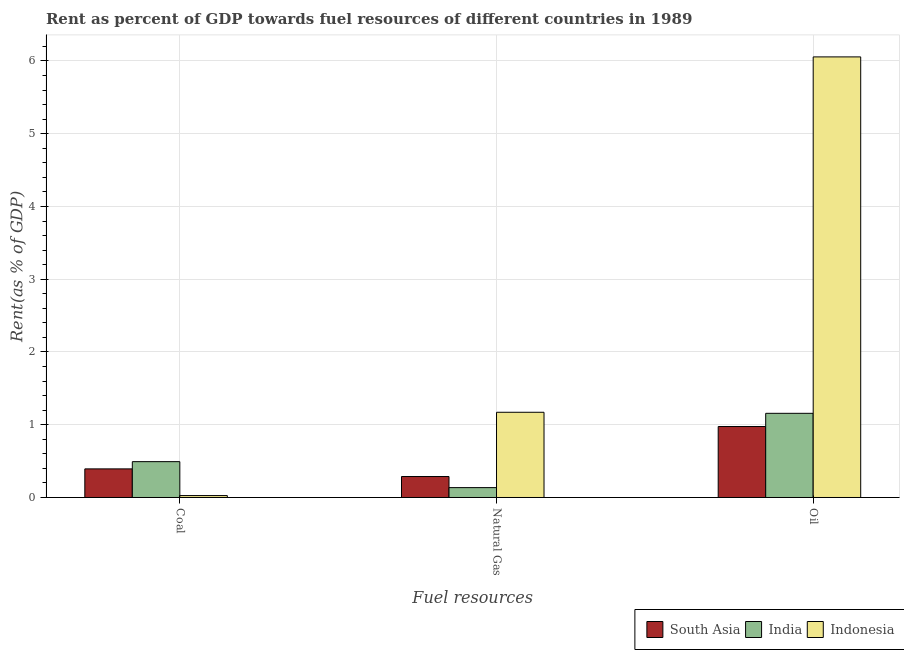How many different coloured bars are there?
Provide a short and direct response. 3. How many bars are there on the 3rd tick from the left?
Your response must be concise. 3. What is the label of the 2nd group of bars from the left?
Keep it short and to the point. Natural Gas. What is the rent towards natural gas in South Asia?
Your answer should be compact. 0.29. Across all countries, what is the maximum rent towards oil?
Keep it short and to the point. 6.06. Across all countries, what is the minimum rent towards coal?
Ensure brevity in your answer.  0.03. In which country was the rent towards coal maximum?
Make the answer very short. India. In which country was the rent towards coal minimum?
Give a very brief answer. Indonesia. What is the total rent towards oil in the graph?
Provide a short and direct response. 8.19. What is the difference between the rent towards oil in South Asia and that in India?
Make the answer very short. -0.18. What is the difference between the rent towards coal in South Asia and the rent towards natural gas in Indonesia?
Keep it short and to the point. -0.78. What is the average rent towards natural gas per country?
Keep it short and to the point. 0.53. What is the difference between the rent towards coal and rent towards oil in Indonesia?
Keep it short and to the point. -6.03. In how many countries, is the rent towards natural gas greater than 1.6 %?
Give a very brief answer. 0. What is the ratio of the rent towards coal in India to that in Indonesia?
Your response must be concise. 18.74. Is the rent towards oil in India less than that in South Asia?
Keep it short and to the point. No. Is the difference between the rent towards coal in India and South Asia greater than the difference between the rent towards natural gas in India and South Asia?
Provide a succinct answer. Yes. What is the difference between the highest and the second highest rent towards oil?
Provide a succinct answer. 4.9. What is the difference between the highest and the lowest rent towards natural gas?
Your answer should be very brief. 1.04. In how many countries, is the rent towards oil greater than the average rent towards oil taken over all countries?
Your answer should be compact. 1. What does the 2nd bar from the left in Coal represents?
Your answer should be very brief. India. What does the 1st bar from the right in Oil represents?
Keep it short and to the point. Indonesia. Are the values on the major ticks of Y-axis written in scientific E-notation?
Keep it short and to the point. No. Does the graph contain grids?
Provide a succinct answer. Yes. How many legend labels are there?
Provide a succinct answer. 3. How are the legend labels stacked?
Offer a very short reply. Horizontal. What is the title of the graph?
Offer a terse response. Rent as percent of GDP towards fuel resources of different countries in 1989. Does "Honduras" appear as one of the legend labels in the graph?
Ensure brevity in your answer.  No. What is the label or title of the X-axis?
Offer a very short reply. Fuel resources. What is the label or title of the Y-axis?
Give a very brief answer. Rent(as % of GDP). What is the Rent(as % of GDP) in South Asia in Coal?
Give a very brief answer. 0.39. What is the Rent(as % of GDP) of India in Coal?
Ensure brevity in your answer.  0.49. What is the Rent(as % of GDP) of Indonesia in Coal?
Make the answer very short. 0.03. What is the Rent(as % of GDP) in South Asia in Natural Gas?
Ensure brevity in your answer.  0.29. What is the Rent(as % of GDP) in India in Natural Gas?
Ensure brevity in your answer.  0.14. What is the Rent(as % of GDP) in Indonesia in Natural Gas?
Give a very brief answer. 1.17. What is the Rent(as % of GDP) of South Asia in Oil?
Keep it short and to the point. 0.98. What is the Rent(as % of GDP) in India in Oil?
Offer a terse response. 1.16. What is the Rent(as % of GDP) of Indonesia in Oil?
Keep it short and to the point. 6.06. Across all Fuel resources, what is the maximum Rent(as % of GDP) of South Asia?
Ensure brevity in your answer.  0.98. Across all Fuel resources, what is the maximum Rent(as % of GDP) of India?
Provide a succinct answer. 1.16. Across all Fuel resources, what is the maximum Rent(as % of GDP) of Indonesia?
Offer a terse response. 6.06. Across all Fuel resources, what is the minimum Rent(as % of GDP) of South Asia?
Your answer should be compact. 0.29. Across all Fuel resources, what is the minimum Rent(as % of GDP) of India?
Ensure brevity in your answer.  0.14. Across all Fuel resources, what is the minimum Rent(as % of GDP) in Indonesia?
Your response must be concise. 0.03. What is the total Rent(as % of GDP) of South Asia in the graph?
Provide a short and direct response. 1.66. What is the total Rent(as % of GDP) in India in the graph?
Provide a short and direct response. 1.78. What is the total Rent(as % of GDP) of Indonesia in the graph?
Offer a very short reply. 7.25. What is the difference between the Rent(as % of GDP) of South Asia in Coal and that in Natural Gas?
Keep it short and to the point. 0.1. What is the difference between the Rent(as % of GDP) in India in Coal and that in Natural Gas?
Your answer should be very brief. 0.36. What is the difference between the Rent(as % of GDP) in Indonesia in Coal and that in Natural Gas?
Give a very brief answer. -1.14. What is the difference between the Rent(as % of GDP) of South Asia in Coal and that in Oil?
Provide a succinct answer. -0.58. What is the difference between the Rent(as % of GDP) of India in Coal and that in Oil?
Your response must be concise. -0.66. What is the difference between the Rent(as % of GDP) in Indonesia in Coal and that in Oil?
Your response must be concise. -6.03. What is the difference between the Rent(as % of GDP) of South Asia in Natural Gas and that in Oil?
Ensure brevity in your answer.  -0.69. What is the difference between the Rent(as % of GDP) in India in Natural Gas and that in Oil?
Give a very brief answer. -1.02. What is the difference between the Rent(as % of GDP) in Indonesia in Natural Gas and that in Oil?
Offer a very short reply. -4.88. What is the difference between the Rent(as % of GDP) in South Asia in Coal and the Rent(as % of GDP) in India in Natural Gas?
Your response must be concise. 0.26. What is the difference between the Rent(as % of GDP) of South Asia in Coal and the Rent(as % of GDP) of Indonesia in Natural Gas?
Your answer should be very brief. -0.78. What is the difference between the Rent(as % of GDP) of India in Coal and the Rent(as % of GDP) of Indonesia in Natural Gas?
Offer a very short reply. -0.68. What is the difference between the Rent(as % of GDP) in South Asia in Coal and the Rent(as % of GDP) in India in Oil?
Your answer should be compact. -0.76. What is the difference between the Rent(as % of GDP) of South Asia in Coal and the Rent(as % of GDP) of Indonesia in Oil?
Provide a succinct answer. -5.66. What is the difference between the Rent(as % of GDP) in India in Coal and the Rent(as % of GDP) in Indonesia in Oil?
Make the answer very short. -5.56. What is the difference between the Rent(as % of GDP) in South Asia in Natural Gas and the Rent(as % of GDP) in India in Oil?
Offer a terse response. -0.87. What is the difference between the Rent(as % of GDP) of South Asia in Natural Gas and the Rent(as % of GDP) of Indonesia in Oil?
Your response must be concise. -5.77. What is the difference between the Rent(as % of GDP) in India in Natural Gas and the Rent(as % of GDP) in Indonesia in Oil?
Ensure brevity in your answer.  -5.92. What is the average Rent(as % of GDP) of South Asia per Fuel resources?
Your answer should be very brief. 0.55. What is the average Rent(as % of GDP) in India per Fuel resources?
Ensure brevity in your answer.  0.59. What is the average Rent(as % of GDP) of Indonesia per Fuel resources?
Provide a succinct answer. 2.42. What is the difference between the Rent(as % of GDP) in South Asia and Rent(as % of GDP) in India in Coal?
Ensure brevity in your answer.  -0.1. What is the difference between the Rent(as % of GDP) in South Asia and Rent(as % of GDP) in Indonesia in Coal?
Make the answer very short. 0.37. What is the difference between the Rent(as % of GDP) of India and Rent(as % of GDP) of Indonesia in Coal?
Your answer should be very brief. 0.47. What is the difference between the Rent(as % of GDP) of South Asia and Rent(as % of GDP) of India in Natural Gas?
Provide a short and direct response. 0.15. What is the difference between the Rent(as % of GDP) in South Asia and Rent(as % of GDP) in Indonesia in Natural Gas?
Make the answer very short. -0.88. What is the difference between the Rent(as % of GDP) in India and Rent(as % of GDP) in Indonesia in Natural Gas?
Provide a succinct answer. -1.04. What is the difference between the Rent(as % of GDP) of South Asia and Rent(as % of GDP) of India in Oil?
Your answer should be very brief. -0.18. What is the difference between the Rent(as % of GDP) in South Asia and Rent(as % of GDP) in Indonesia in Oil?
Your answer should be very brief. -5.08. What is the difference between the Rent(as % of GDP) of India and Rent(as % of GDP) of Indonesia in Oil?
Make the answer very short. -4.9. What is the ratio of the Rent(as % of GDP) of South Asia in Coal to that in Natural Gas?
Your response must be concise. 1.36. What is the ratio of the Rent(as % of GDP) of India in Coal to that in Natural Gas?
Provide a succinct answer. 3.63. What is the ratio of the Rent(as % of GDP) in Indonesia in Coal to that in Natural Gas?
Provide a succinct answer. 0.02. What is the ratio of the Rent(as % of GDP) of South Asia in Coal to that in Oil?
Provide a short and direct response. 0.4. What is the ratio of the Rent(as % of GDP) of India in Coal to that in Oil?
Keep it short and to the point. 0.43. What is the ratio of the Rent(as % of GDP) in Indonesia in Coal to that in Oil?
Give a very brief answer. 0. What is the ratio of the Rent(as % of GDP) in South Asia in Natural Gas to that in Oil?
Provide a succinct answer. 0.3. What is the ratio of the Rent(as % of GDP) in India in Natural Gas to that in Oil?
Give a very brief answer. 0.12. What is the ratio of the Rent(as % of GDP) of Indonesia in Natural Gas to that in Oil?
Offer a terse response. 0.19. What is the difference between the highest and the second highest Rent(as % of GDP) in South Asia?
Your answer should be very brief. 0.58. What is the difference between the highest and the second highest Rent(as % of GDP) in India?
Provide a short and direct response. 0.66. What is the difference between the highest and the second highest Rent(as % of GDP) in Indonesia?
Make the answer very short. 4.88. What is the difference between the highest and the lowest Rent(as % of GDP) of South Asia?
Your answer should be compact. 0.69. What is the difference between the highest and the lowest Rent(as % of GDP) of India?
Offer a very short reply. 1.02. What is the difference between the highest and the lowest Rent(as % of GDP) of Indonesia?
Provide a short and direct response. 6.03. 